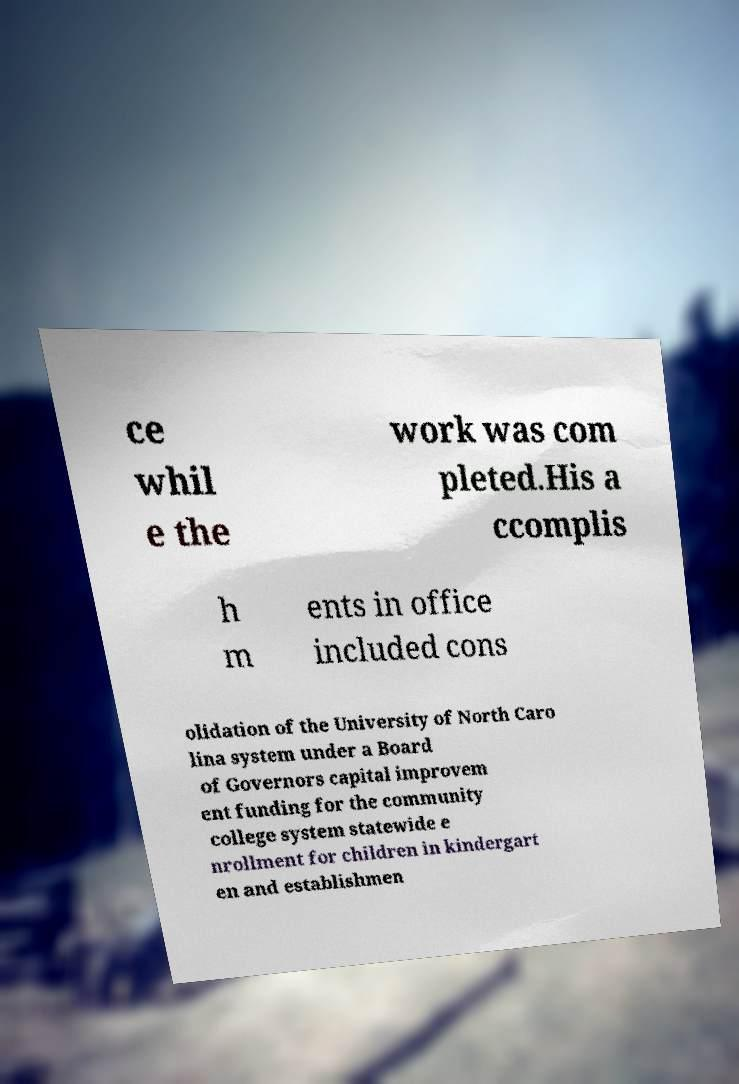Can you accurately transcribe the text from the provided image for me? ce whil e the work was com pleted.His a ccomplis h m ents in office included cons olidation of the University of North Caro lina system under a Board of Governors capital improvem ent funding for the community college system statewide e nrollment for children in kindergart en and establishmen 